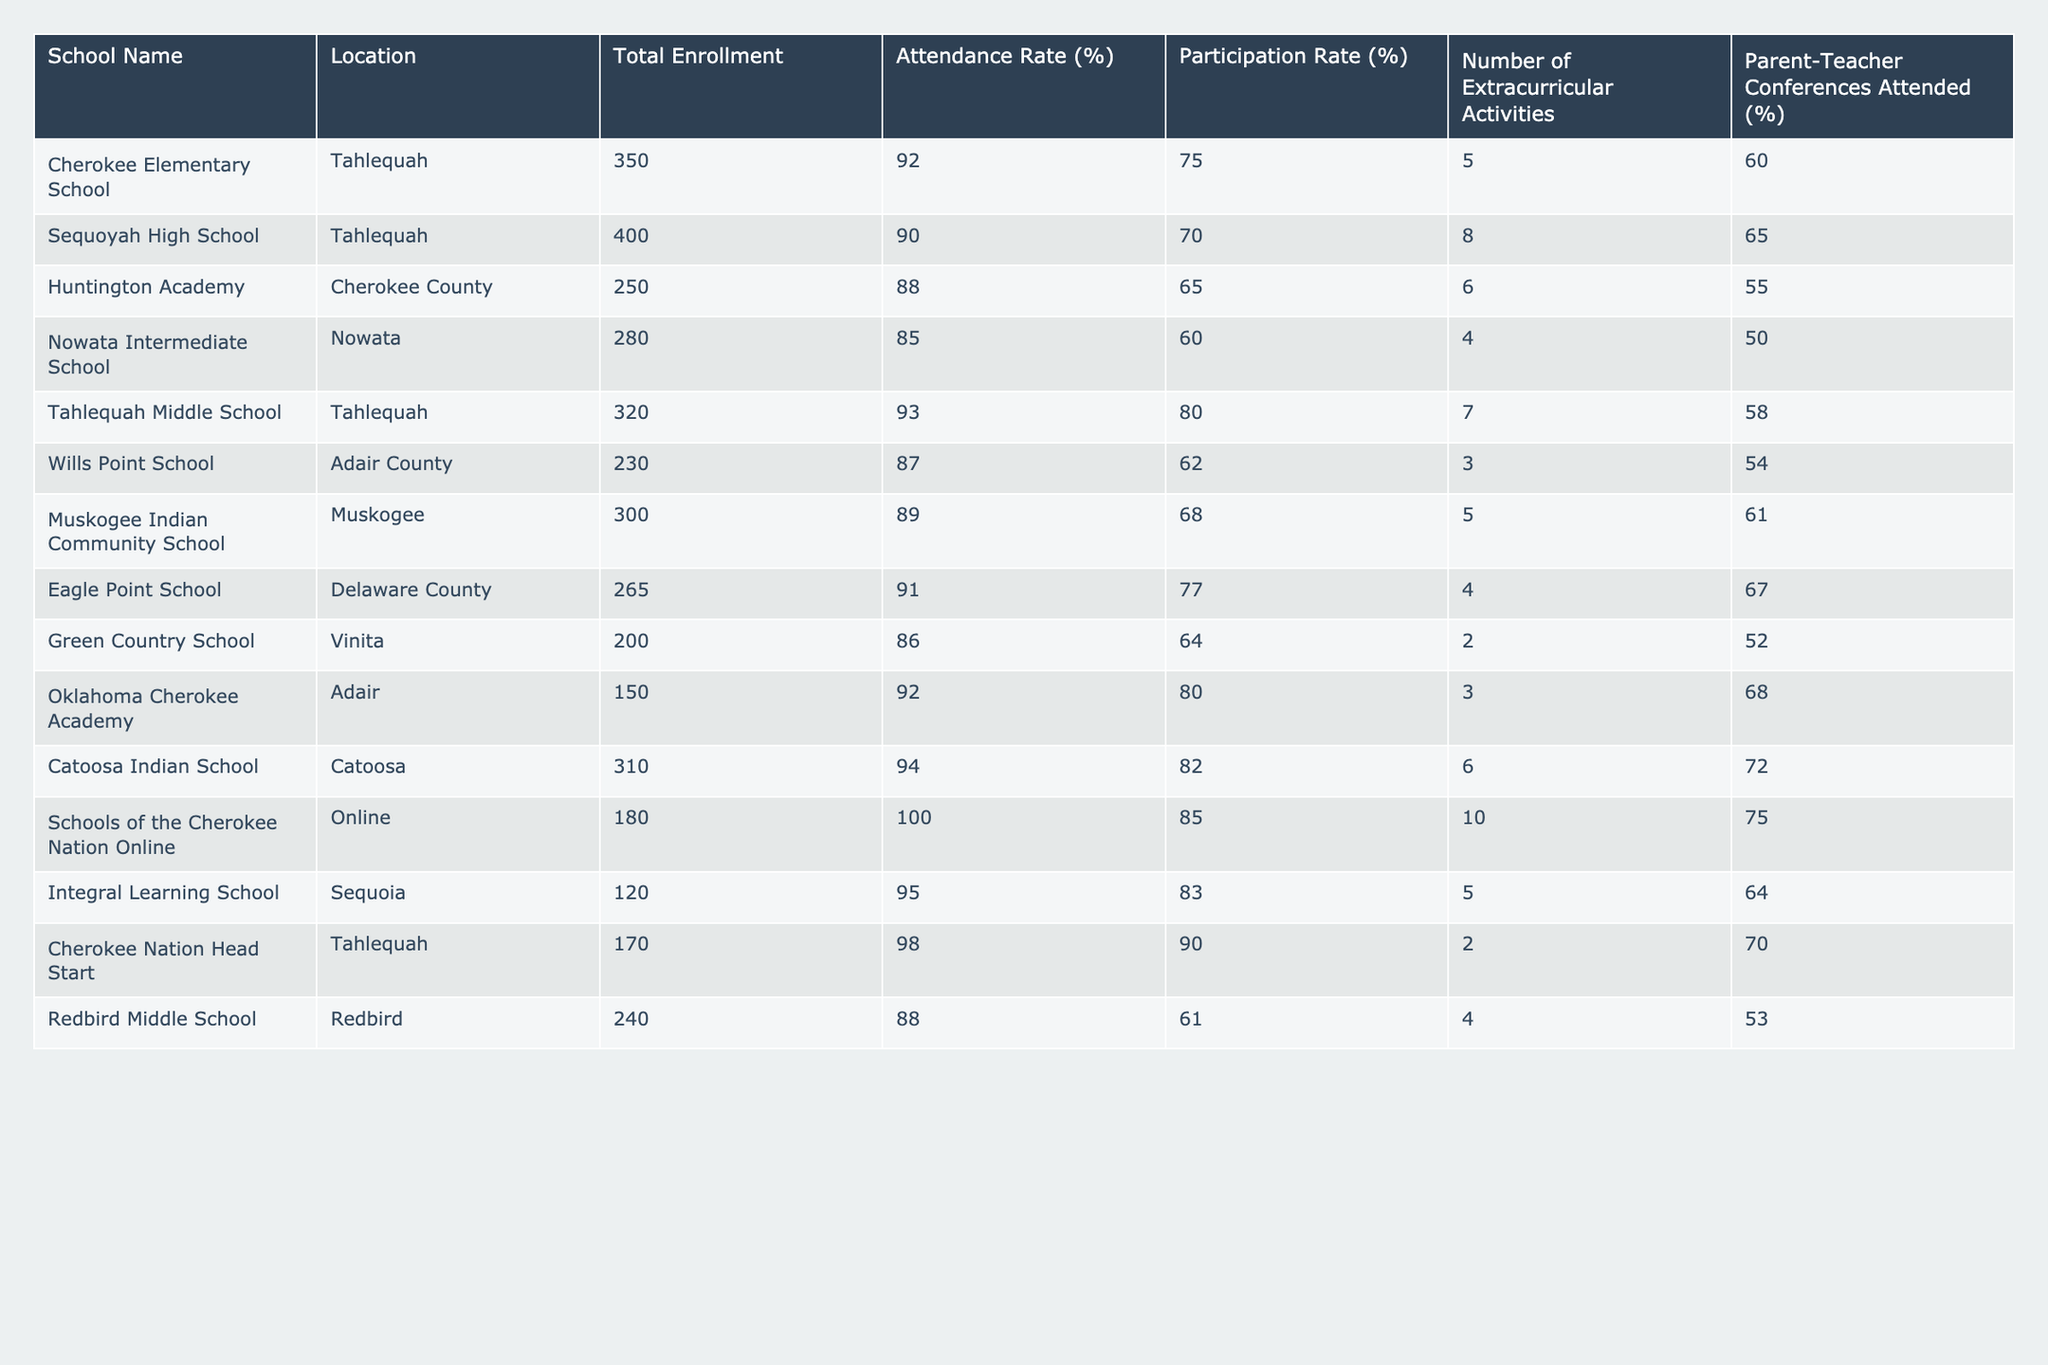What is the attendance rate of Cherokee Elementary School? The attendance rate for Cherokee Elementary School is given directly in the table under the "Attendance Rate (%)" column. It shows a value of 92%.
Answer: 92% Which school has the highest participation rate? To determine the highest participation rate, I will look for the maximum value in the "Participation Rate (%)" column. The highest value is 90% from Cherokee Nation Head Start.
Answer: 90% What is the average attendance rate for schools in Tahlequah? The schools in Tahlequah listed are Cherokee Elementary School, Sequoyah High School, Tahlequah Middle School, and Cherokee Nation Head Start. Their attendance rates are 92%, 90%, 93%, and 98%. The average is (92 + 90 + 93 + 98) / 4 = 93.25%.
Answer: 93.25% Does Wills Point School have a higher attendance rate than Nowata Intermediate School? The attendance rate for Wills Point School is 87%, and for Nowata Intermediate School, it is 85%. Since 87% is greater than 85%, Wills Point School does have a higher attendance rate.
Answer: Yes How many total extracurricular activities are available across all schools? I will sum up the values in the "Number of Extracurricular Activities" column: 5 + 8 + 6 + 4 + 7 + 3 + 5 + 4 + 2 + 3 + 10 + 5 + 2 + 4 = 66. Therefore, there are 66 extracurricular activities in total.
Answer: 66 What percent of parents attended the parent-teacher conferences at Muskogee Indian Community School? The percentage of parents who attended the conferences is provided in the table for Muskogee Indian Community School under "Parent-Teacher Conferences Attended (%)". This value is 61%.
Answer: 61% Which school has the lowest total enrollment? By checking the "Total Enrollment" column, I find that the school with the lowest total enrollment is Integral Learning School with an enrollment of 120 students.
Answer: 120 What is the difference in participation rates between the school with the highest and the school with the lowest participation rates? The highest participation rate is from Cherokee Nation Head Start at 90%, and the lowest is from Huntington Academy at 65%. The difference is 90% - 65% = 25%.
Answer: 25% How many schools have an attendance rate of 90% or higher? I will count the number of schools listed in the table with attendance rates of 90% or above: Cherokee Elementary School, Sequoyah High School, Tahlequah Middle School, Cherokee Nation Head Start, Catoosa Indian School, Schools of the Cherokee Nation Online, and Oklahoma Cherokee Academy. This results in a total of 7 schools.
Answer: 7 Which school has the lowest percentage of parent-teacher conferences attended? I will find the lowest value in the "Parent-Teacher Conferences Attended (%)" column. The lowest attendance percentage is from Nowata Intermediate School at 50%.
Answer: 50% Is it true that all schools have an attendance rate above 80%? To verify this, I check the attendance rates: Nowata Intermediate School has an attendance rate of 85%, which is above 80%. However, Redbird Middle School has an attendance rate of 88%, which is still above 80%. Therefore, yes, all schools have an attendance rate above 80%.
Answer: Yes 